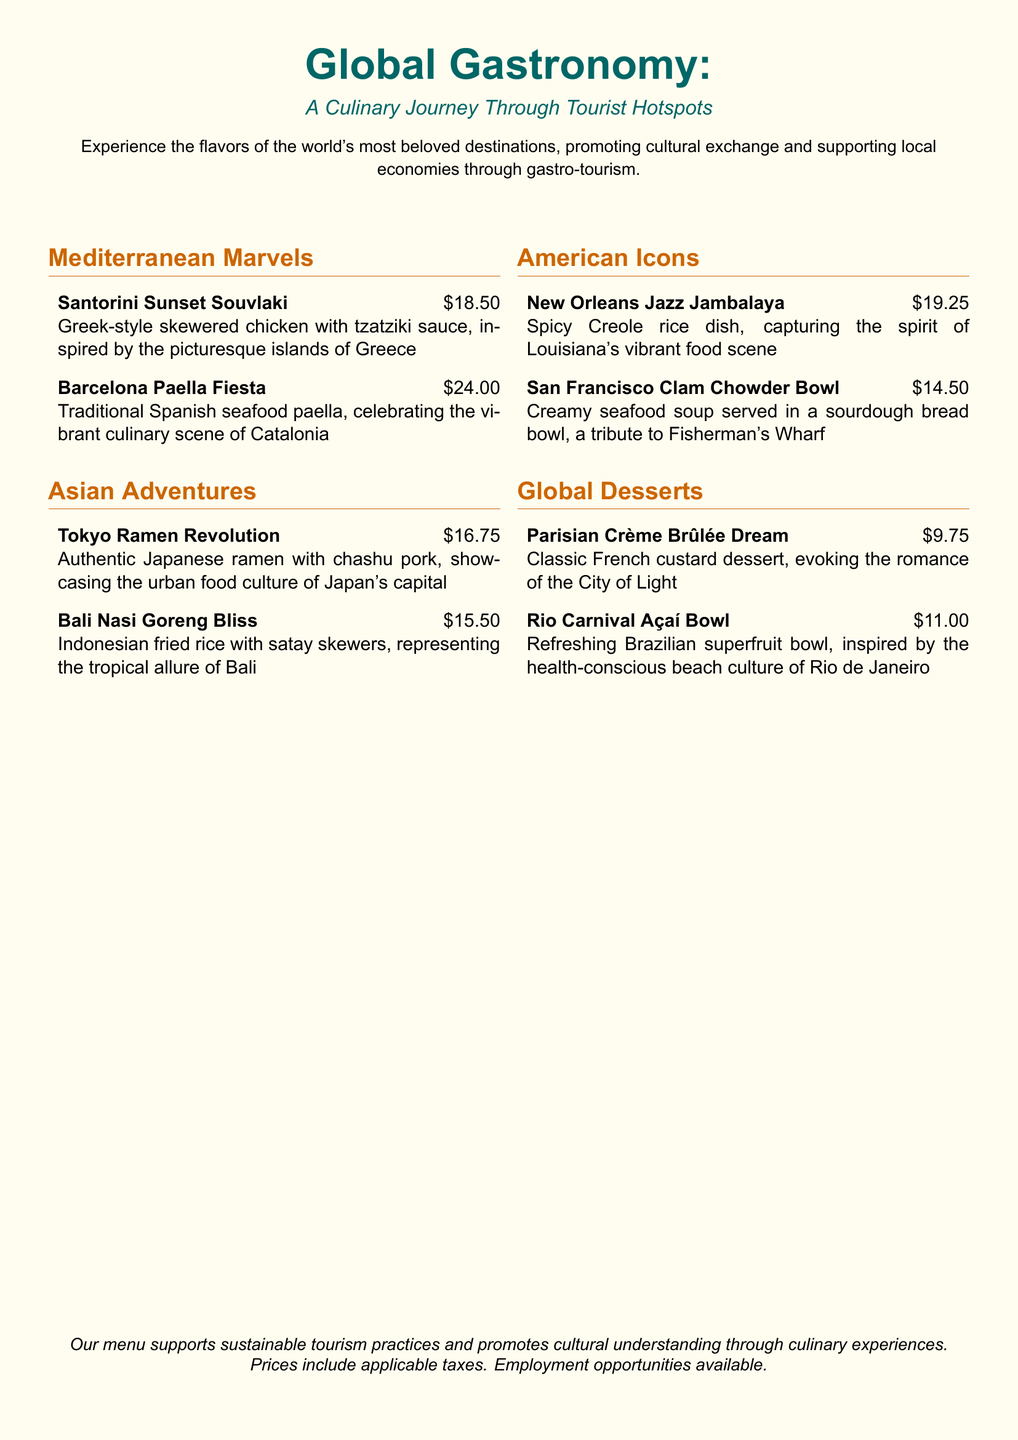What is the title of the menu? The title of the menu is prominently featured at the top of the document as "Global Gastronomy."
Answer: Global Gastronomy How many sections are in the menu? The document outlines four distinct sections, each representing different culinary themes.
Answer: Four What is the price of the Barcelona Paella Fiesta? The price for this specific dish is listed alongside its description in the menu.
Answer: $24.00 Which dish represents the tropical allure of Bali? The dish that is inspired by the culture of Bali is explicitly mentioned in the Asian Adventures section.
Answer: Bali Nasi Goreng Bliss What is the main ingredient in the Tokyo Ramen Revolution? The menu indicates that chashu pork is a key ingredient in this ramen dish.
Answer: Chashu pork Which dessert is inspired by the City of Light? The dessert evoking the romance of Paris is named in the Global Desserts section.
Answer: Parisian Crème Brûlée Dream What type of cuisine does the San Francisco Clam Chowder Bowl represent? This dish is described in a section that focuses on American regional specialties.
Answer: American How much is the Rio Carnival Açaí Bowl? The price for this particular dessert is provided in the menu alongside its name.
Answer: $11.00 